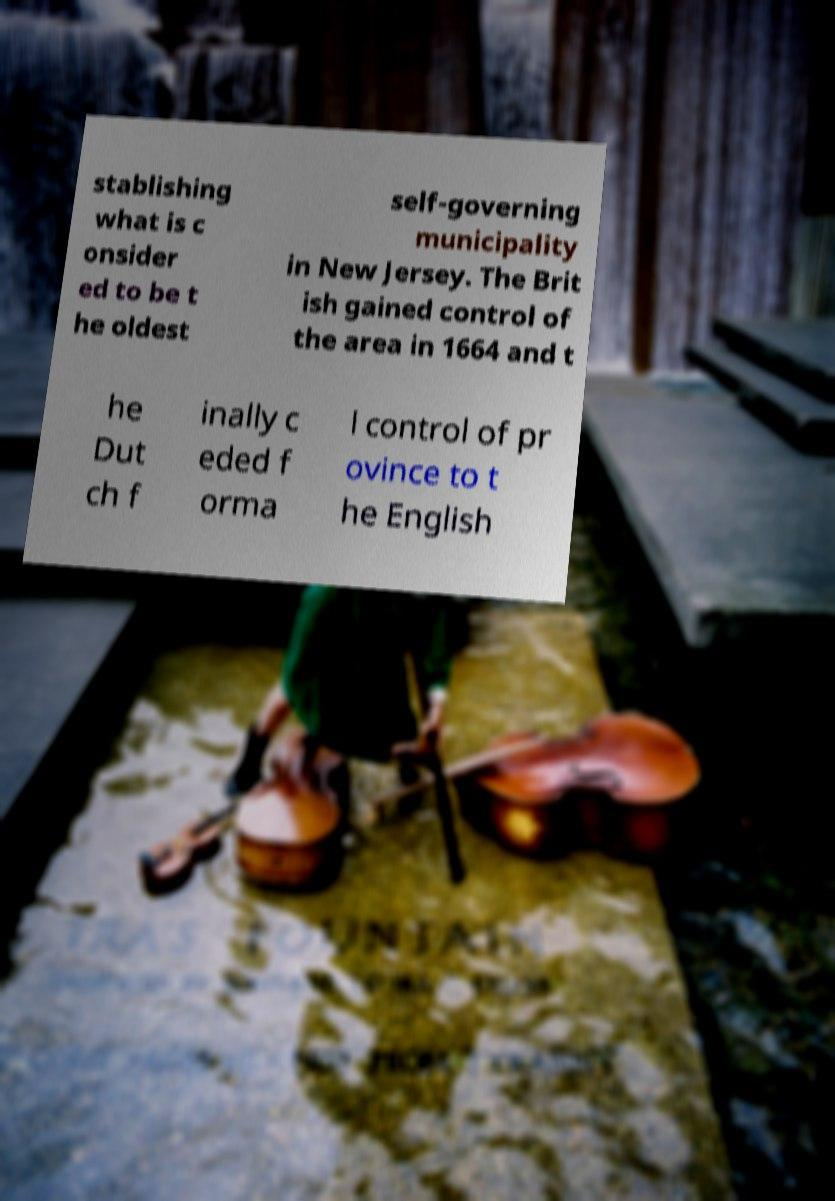For documentation purposes, I need the text within this image transcribed. Could you provide that? stablishing what is c onsider ed to be t he oldest self-governing municipality in New Jersey. The Brit ish gained control of the area in 1664 and t he Dut ch f inally c eded f orma l control of pr ovince to t he English 